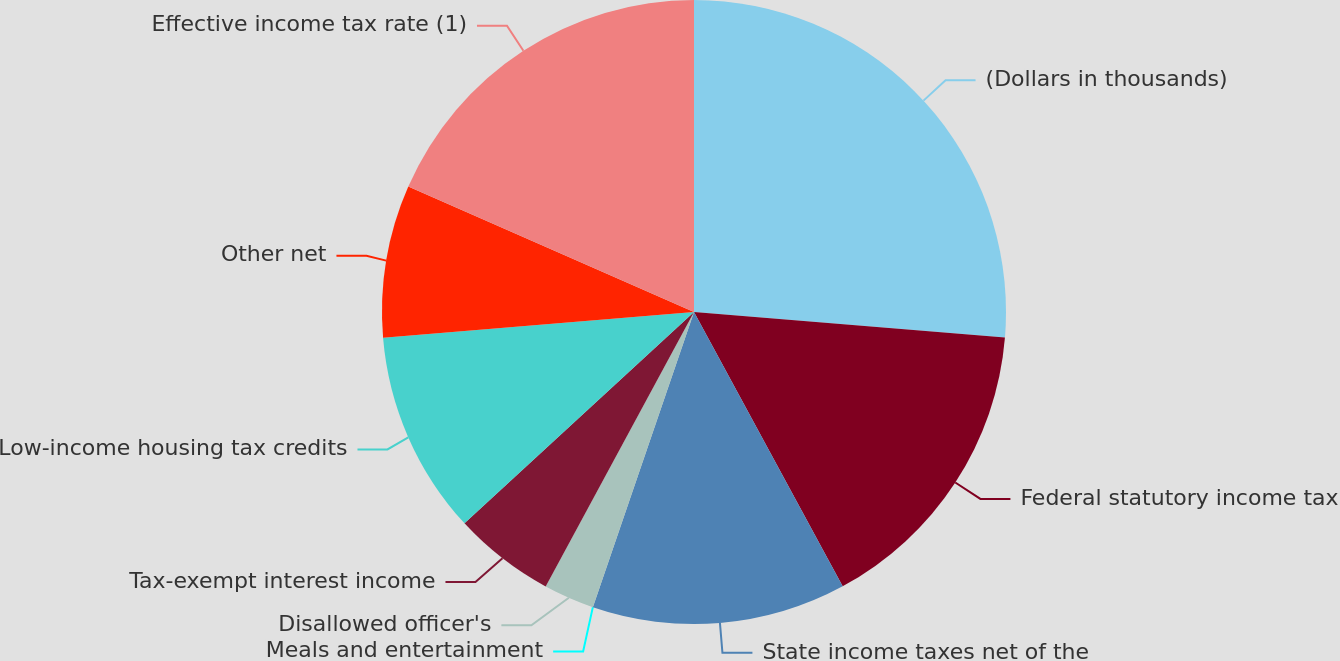Convert chart to OTSL. <chart><loc_0><loc_0><loc_500><loc_500><pie_chart><fcel>(Dollars in thousands)<fcel>Federal statutory income tax<fcel>State income taxes net of the<fcel>Meals and entertainment<fcel>Disallowed officer's<fcel>Tax-exempt interest income<fcel>Low-income housing tax credits<fcel>Other net<fcel>Effective income tax rate (1)<nl><fcel>26.31%<fcel>15.79%<fcel>13.16%<fcel>0.0%<fcel>2.63%<fcel>5.27%<fcel>10.53%<fcel>7.9%<fcel>18.42%<nl></chart> 